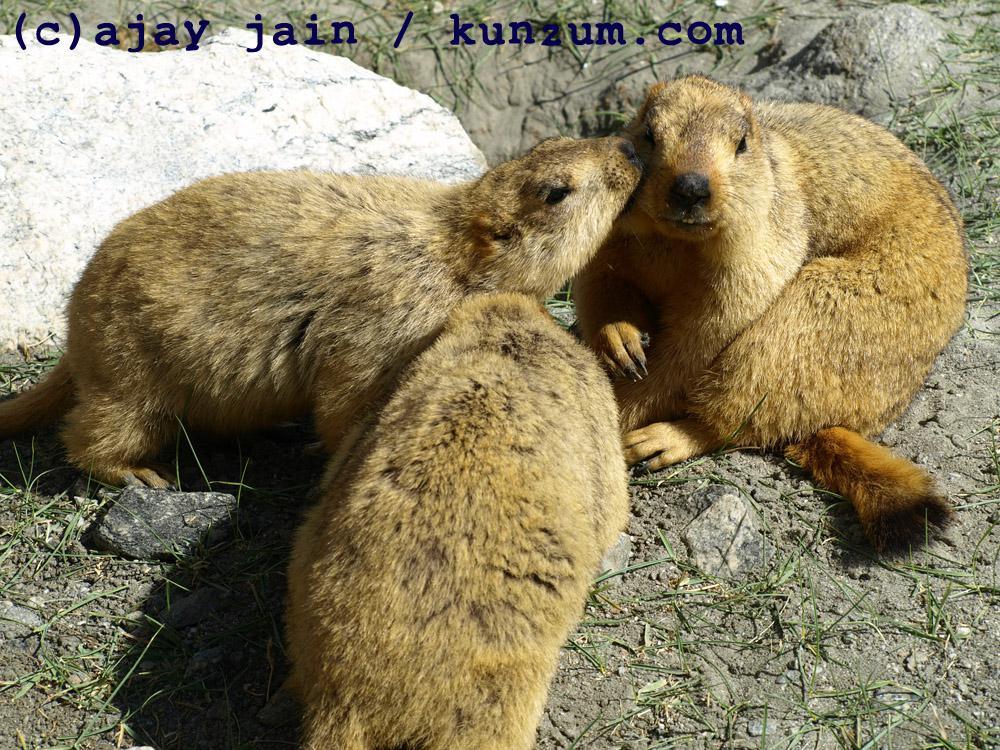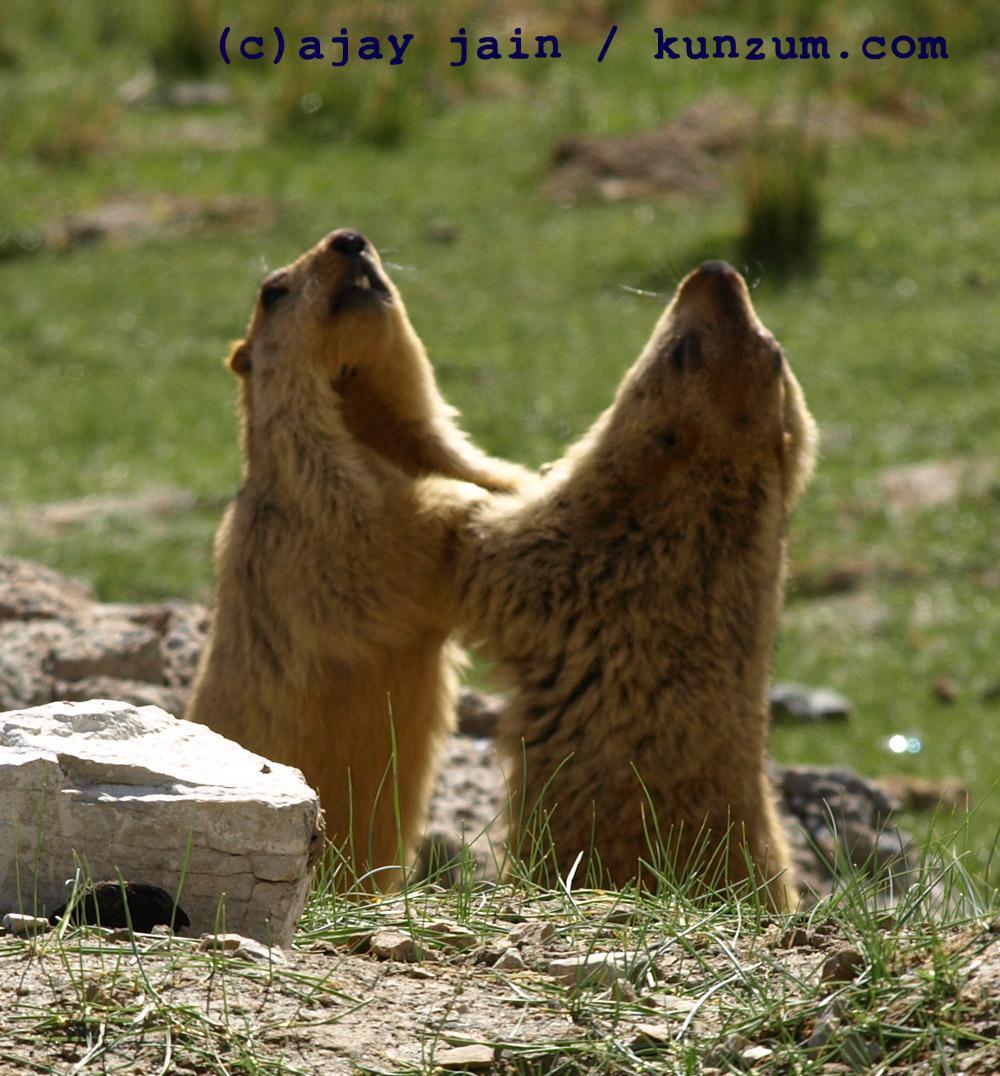The first image is the image on the left, the second image is the image on the right. For the images shown, is this caption "There are two marmots touching in the right image." true? Answer yes or no. Yes. The first image is the image on the left, the second image is the image on the right. Analyze the images presented: Is the assertion "There is a total of three animals in the pair of images." valid? Answer yes or no. No. 